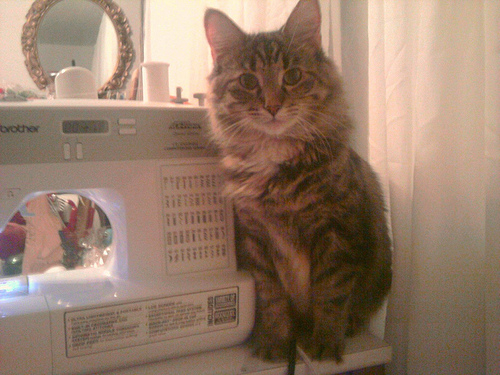<image>
Is the mirror in front of the cat? No. The mirror is not in front of the cat. The spatial positioning shows a different relationship between these objects. Where is the cat in relation to the sewing machine? Is it above the sewing machine? No. The cat is not positioned above the sewing machine. The vertical arrangement shows a different relationship. 